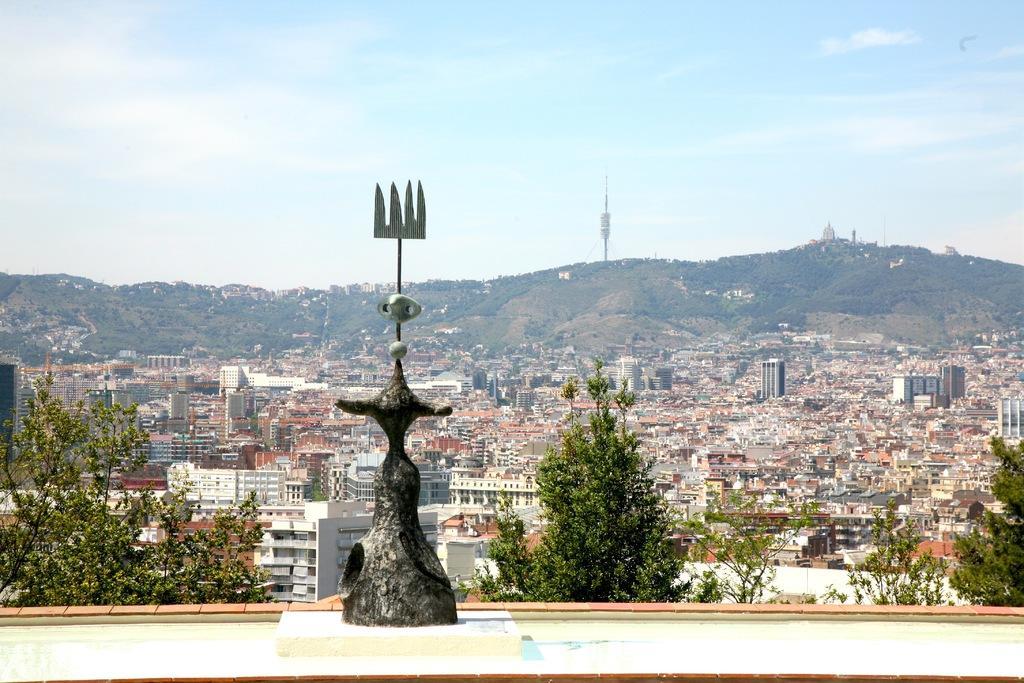Could you give a brief overview of what you see in this image? In this picture we can see a bronze sculpture, trees, buildings, and mountain. In the background there is sky. 